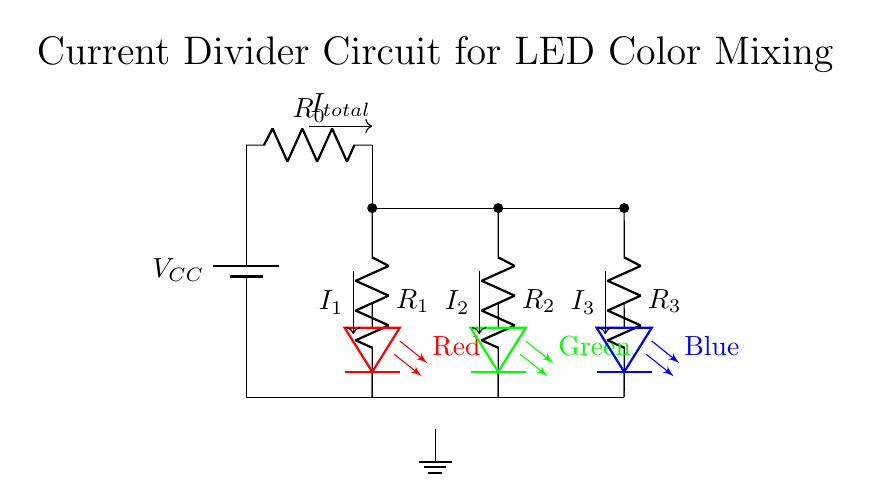What is the total input current of the circuit? The total input current is indicated by the label \( I_{total} \) at the power supply, which would be the sum of the currents flowing through each resistor connected to the LEDs.
Answer: \( I_{total} \) What type of resistors are used in the current divider circuit? The circuit uses resistors labeled as \( R_0 \), \( R_1 \), \( R_2 \), and \( R_3 \). These indicate they are current-limiting resistors in series with the LED branches.
Answer: Resistors Which LED uses the highest current? The LED current depends on the resistances in the branches. Given three resistors \( R_1, R_2, R_3 \) are in parallel, the LED connected to the lowest resistor value will have the highest current. The specific LED cannot be determined without resistor values.
Answer: Unknown What colors are represented by the LEDs in this circuit? The LEDs are colored red, green, and blue, as indicated next to the LED components in the circuit diagram.
Answer: Red, Green, Blue How many branches does the current divider circuit have? The current divider circuit has three branches labeled by the resistors and the corresponding LEDs. They allow the total input current to split into different paths.
Answer: Three What is the purpose of the current-limiting resistor \( R_0 \)? The purpose of \( R_0 \) is to protect the LEDs from excessive current, ensuring that a suitable amount is supplied to the branches while preventing damage.
Answer: Current Limiting What happens to the total current when one LED is removed? Removing one LED would cause the total current to redistribute, as the remaining resistors would still allow current to flow, albeit at a potentially different distribution based on the remaining resistors.
Answer: Redistributes 